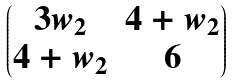Convert formula to latex. <formula><loc_0><loc_0><loc_500><loc_500>\begin{pmatrix} 3 w _ { 2 } & 4 + w _ { 2 } \\ 4 + w _ { 2 } & 6 \end{pmatrix}</formula> 